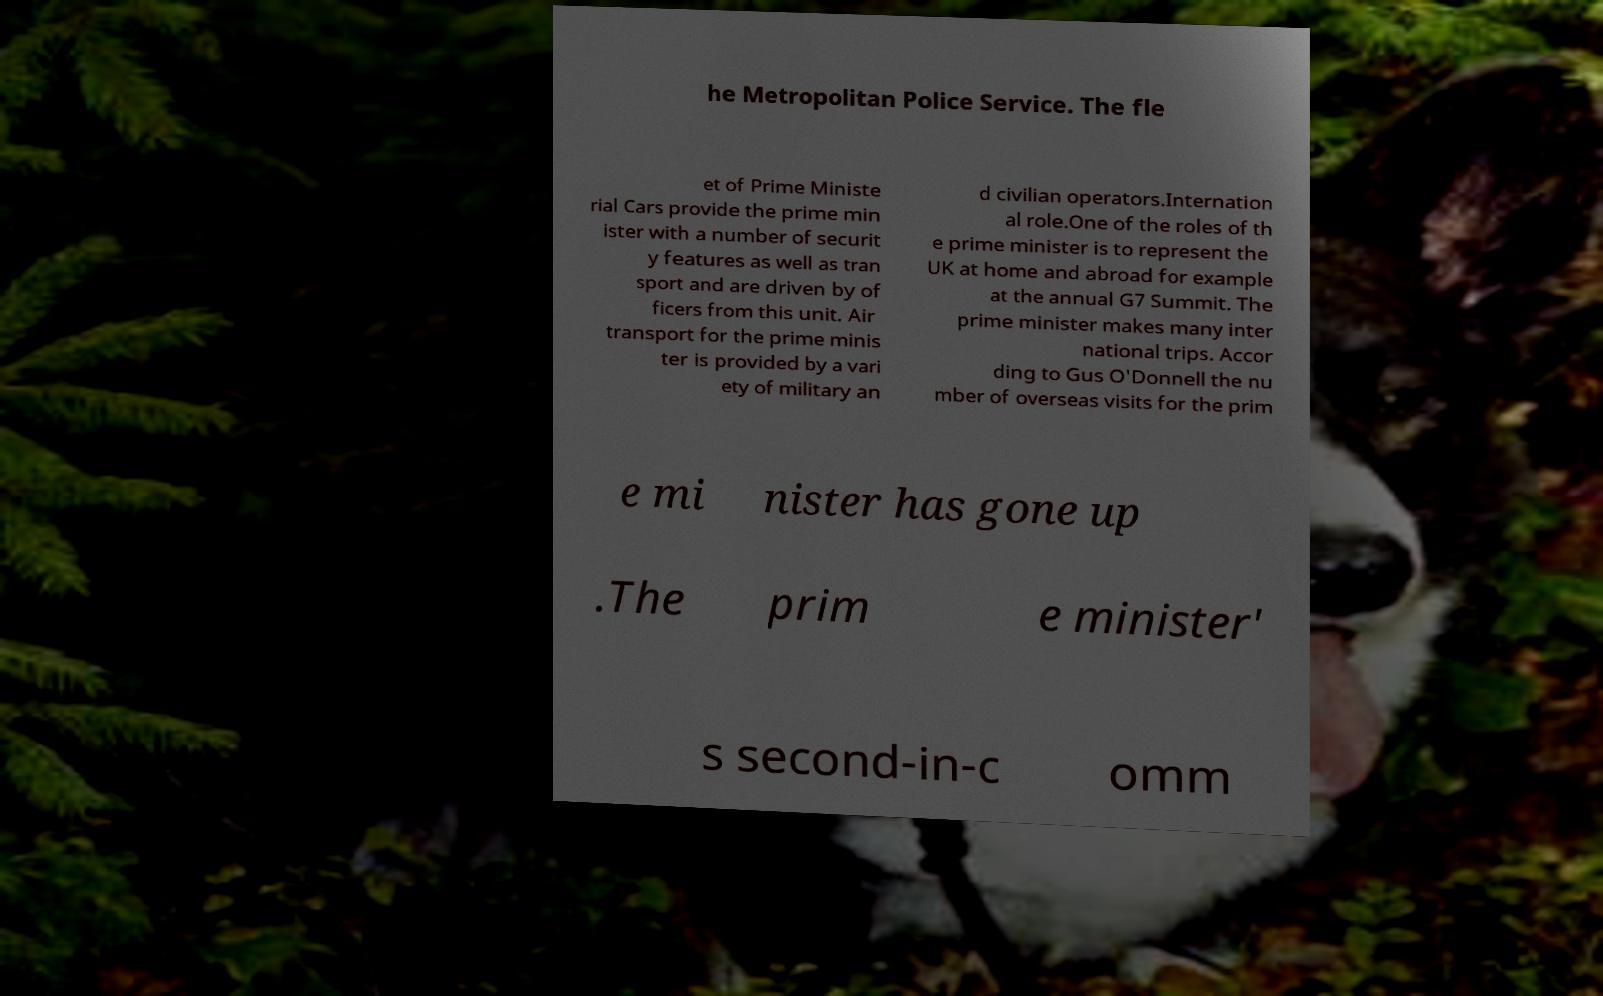What messages or text are displayed in this image? I need them in a readable, typed format. he Metropolitan Police Service. The fle et of Prime Ministe rial Cars provide the prime min ister with a number of securit y features as well as tran sport and are driven by of ficers from this unit. Air transport for the prime minis ter is provided by a vari ety of military an d civilian operators.Internation al role.One of the roles of th e prime minister is to represent the UK at home and abroad for example at the annual G7 Summit. The prime minister makes many inter national trips. Accor ding to Gus O'Donnell the nu mber of overseas visits for the prim e mi nister has gone up .The prim e minister' s second-in-c omm 